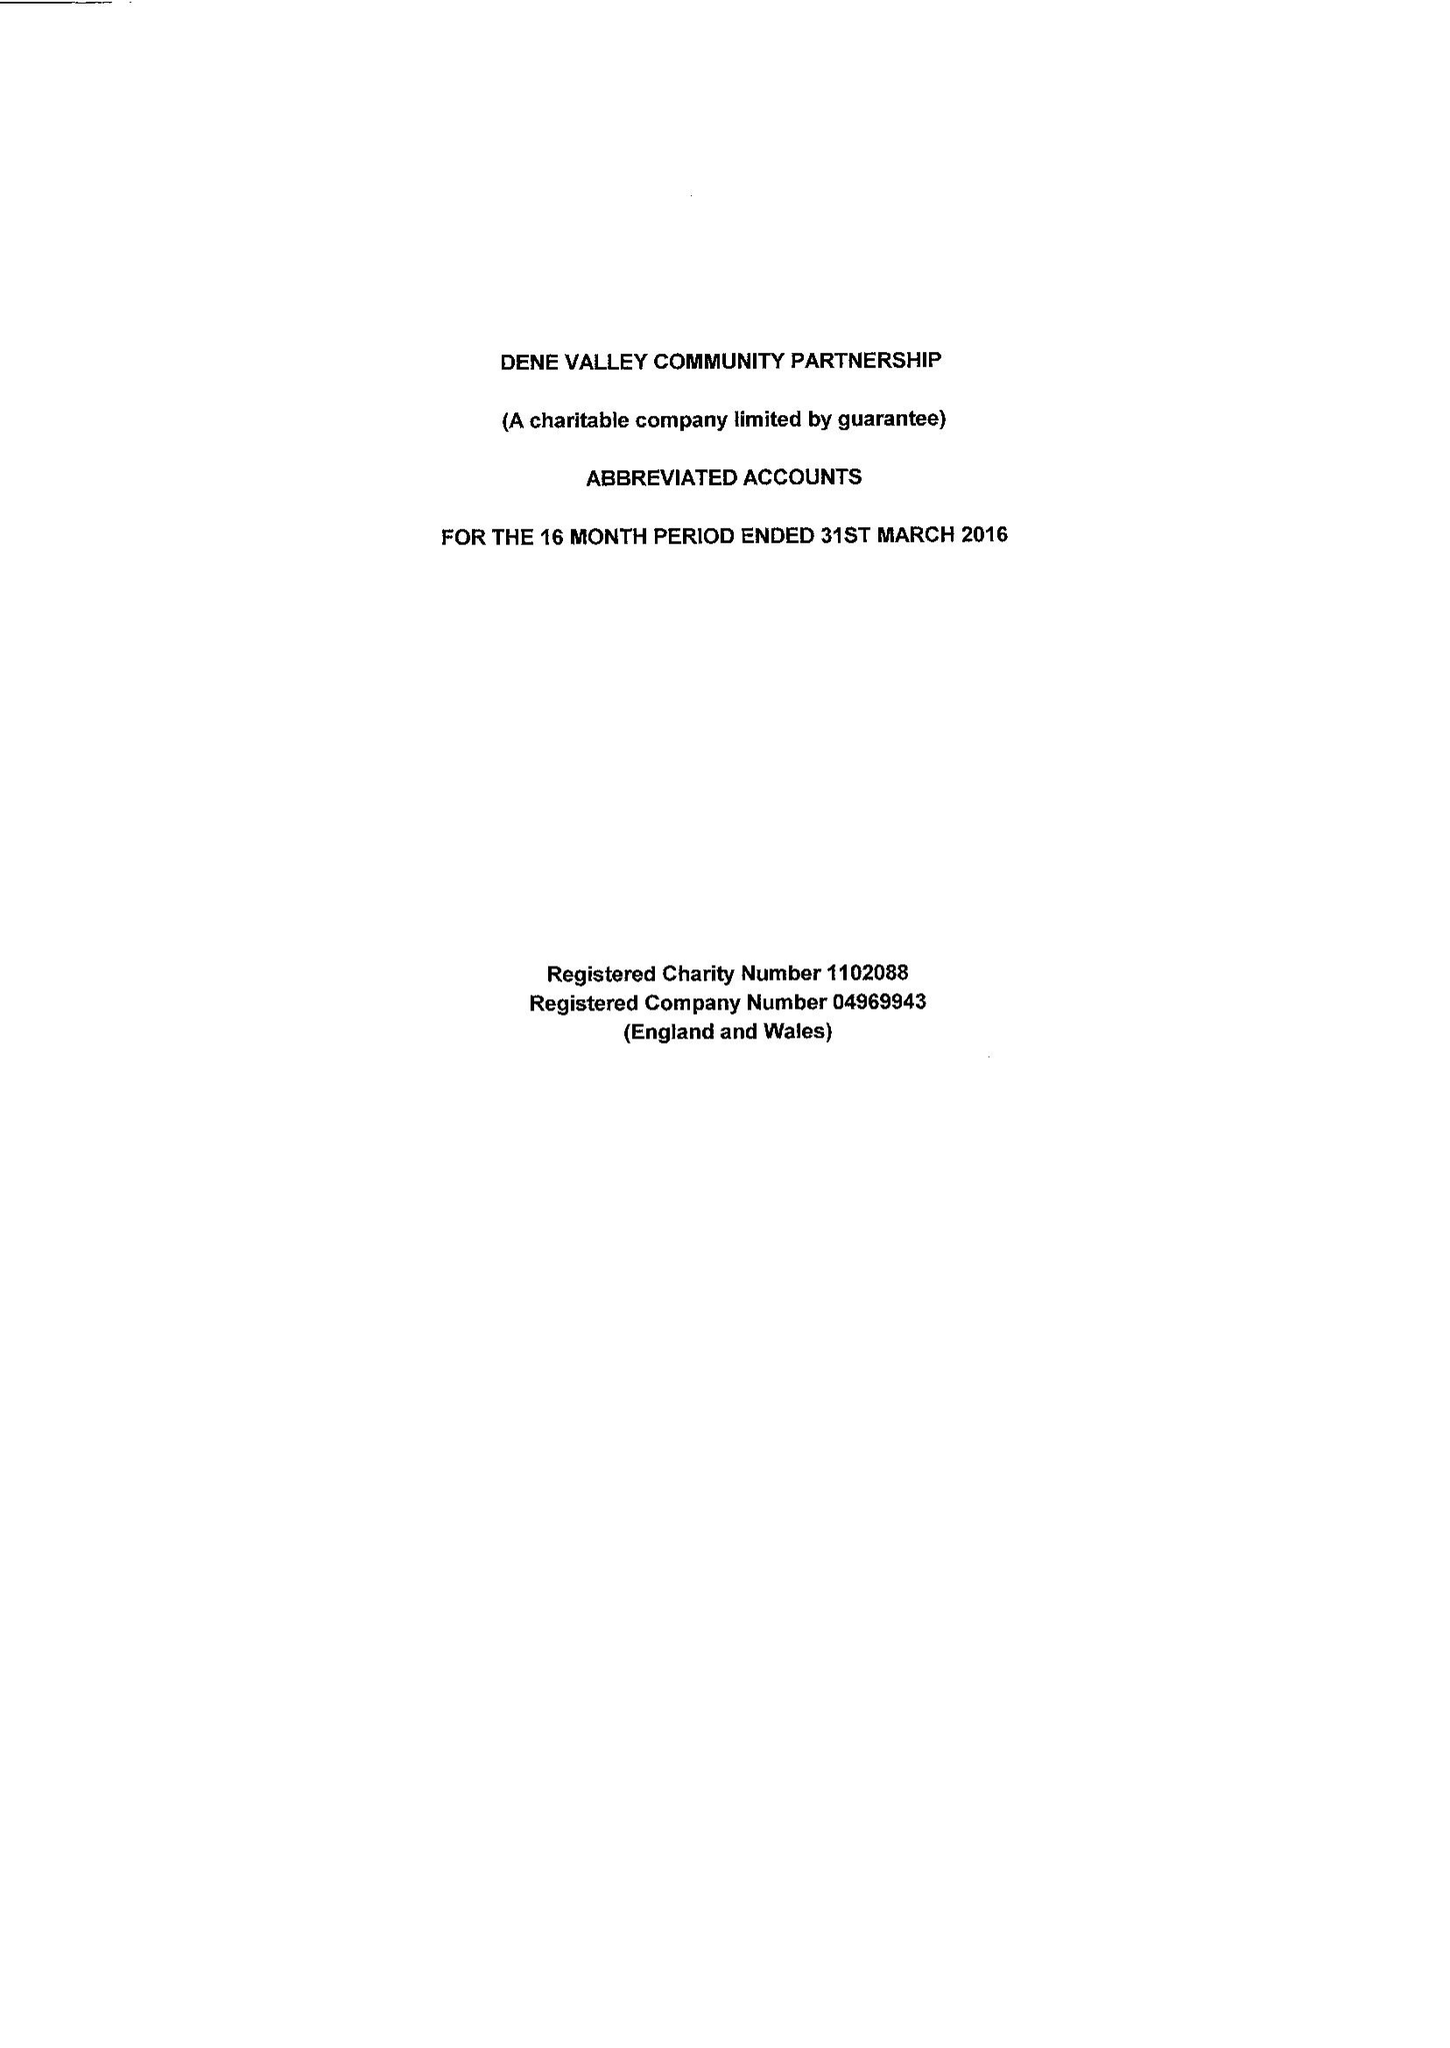What is the value for the address__post_town?
Answer the question using a single word or phrase. BISHOP AUCKLAND 